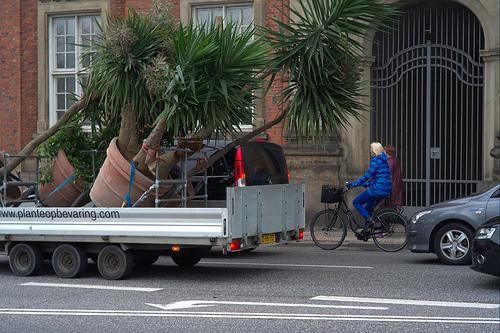Provide a brief caption of what the lady with red hair is doing. The lady with red hair is walking down the sidewalk. How many wheels can be seen on the transport truck? The transport truck has six rear wheels. Describe the interaction between the delivery truck and potted trees in the image. The potted trees are on a flatbed delivery truck, being transported en route to their destination. Mention two objects related to plants in the image. Large potted trees and big brown flower pots. List three objects in the image and their corresponding sizes. A big flower pot (Width:124, Height:124), a grey car (Width:95, Height:95), and a gated entrance (Width:117, Height:117). What is the mode of transportation seen in the image for a lady? A lady is riding a bicycle. What kind of vehicle is directly behind the tree truck? A black car is directly behind the tree truck. How would you describe the clothing of the bicyclist in the image? The bicyclist is wearing bright blue pants. What type of business or building might have the gated entrance? The gated entrance may belong to a residential complex or a commercial building. What might be the function of the service truck in the image? The service truck is used for delivering large potted plants. 